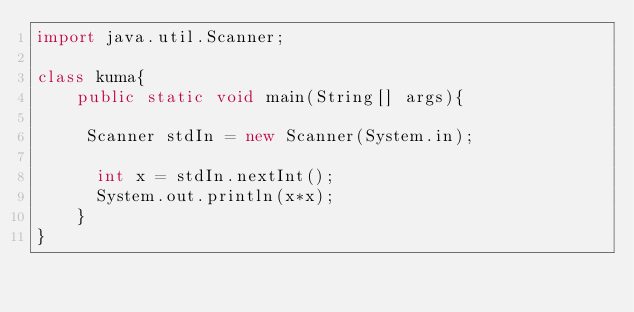<code> <loc_0><loc_0><loc_500><loc_500><_Java_>import java.util.Scanner;
 
class kuma{
  	public static void main(String[] args){
      
     Scanner stdIn = new Scanner(System.in);
      
      int x = stdIn.nextInt();
      System.out.println(x*x);
    }
}</code> 